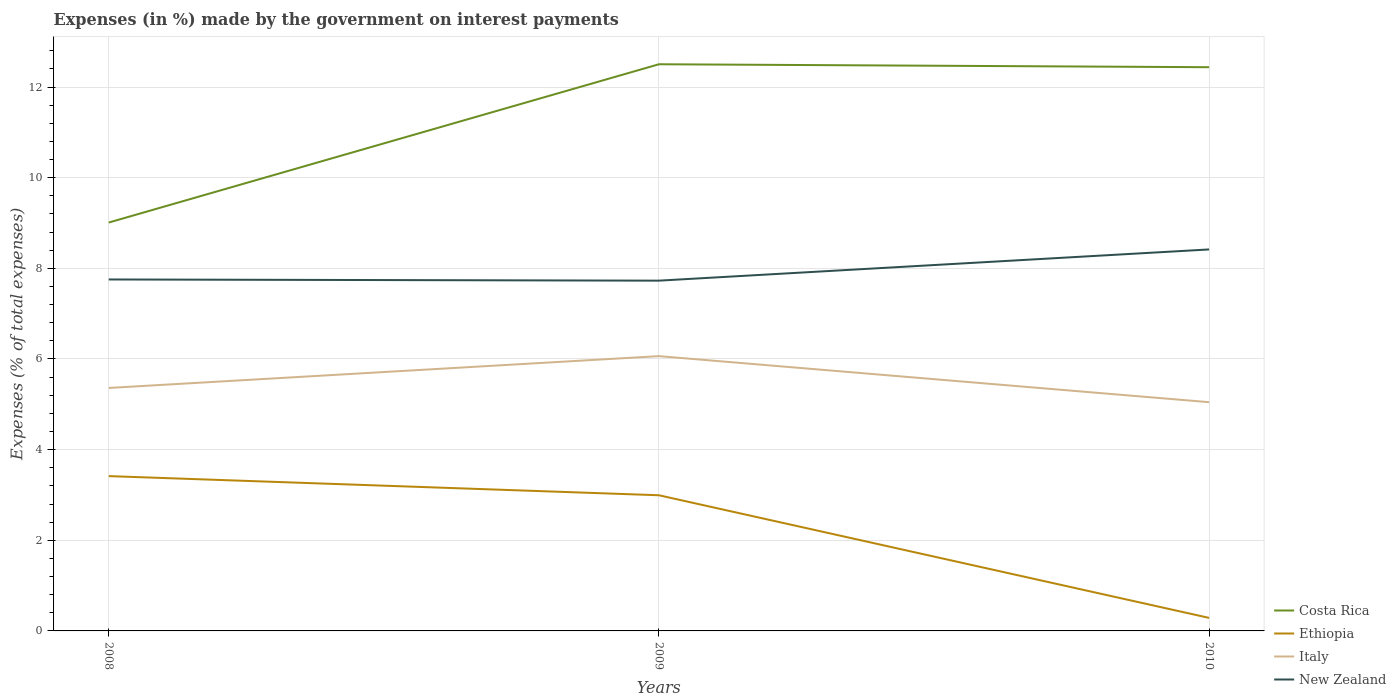How many different coloured lines are there?
Make the answer very short. 4. Does the line corresponding to Ethiopia intersect with the line corresponding to New Zealand?
Provide a short and direct response. No. Across all years, what is the maximum percentage of expenses made by the government on interest payments in Italy?
Your answer should be compact. 5.05. What is the total percentage of expenses made by the government on interest payments in Ethiopia in the graph?
Keep it short and to the point. 3.13. What is the difference between the highest and the second highest percentage of expenses made by the government on interest payments in Costa Rica?
Provide a short and direct response. 3.49. What is the difference between the highest and the lowest percentage of expenses made by the government on interest payments in Costa Rica?
Offer a terse response. 2. Is the percentage of expenses made by the government on interest payments in Italy strictly greater than the percentage of expenses made by the government on interest payments in New Zealand over the years?
Your answer should be very brief. Yes. How many years are there in the graph?
Provide a succinct answer. 3. What is the difference between two consecutive major ticks on the Y-axis?
Give a very brief answer. 2. Are the values on the major ticks of Y-axis written in scientific E-notation?
Provide a short and direct response. No. Does the graph contain any zero values?
Your answer should be very brief. No. Does the graph contain grids?
Keep it short and to the point. Yes. Where does the legend appear in the graph?
Your answer should be very brief. Bottom right. What is the title of the graph?
Provide a succinct answer. Expenses (in %) made by the government on interest payments. What is the label or title of the Y-axis?
Your response must be concise. Expenses (% of total expenses). What is the Expenses (% of total expenses) of Costa Rica in 2008?
Offer a terse response. 9.01. What is the Expenses (% of total expenses) of Ethiopia in 2008?
Your answer should be very brief. 3.42. What is the Expenses (% of total expenses) of Italy in 2008?
Offer a terse response. 5.36. What is the Expenses (% of total expenses) in New Zealand in 2008?
Make the answer very short. 7.75. What is the Expenses (% of total expenses) in Costa Rica in 2009?
Keep it short and to the point. 12.5. What is the Expenses (% of total expenses) in Ethiopia in 2009?
Your answer should be very brief. 2.99. What is the Expenses (% of total expenses) of Italy in 2009?
Provide a short and direct response. 6.06. What is the Expenses (% of total expenses) of New Zealand in 2009?
Provide a short and direct response. 7.73. What is the Expenses (% of total expenses) of Costa Rica in 2010?
Offer a very short reply. 12.44. What is the Expenses (% of total expenses) in Ethiopia in 2010?
Offer a terse response. 0.29. What is the Expenses (% of total expenses) of Italy in 2010?
Provide a short and direct response. 5.05. What is the Expenses (% of total expenses) in New Zealand in 2010?
Make the answer very short. 8.42. Across all years, what is the maximum Expenses (% of total expenses) of Costa Rica?
Provide a short and direct response. 12.5. Across all years, what is the maximum Expenses (% of total expenses) of Ethiopia?
Provide a short and direct response. 3.42. Across all years, what is the maximum Expenses (% of total expenses) in Italy?
Your answer should be compact. 6.06. Across all years, what is the maximum Expenses (% of total expenses) in New Zealand?
Keep it short and to the point. 8.42. Across all years, what is the minimum Expenses (% of total expenses) in Costa Rica?
Keep it short and to the point. 9.01. Across all years, what is the minimum Expenses (% of total expenses) of Ethiopia?
Ensure brevity in your answer.  0.29. Across all years, what is the minimum Expenses (% of total expenses) in Italy?
Offer a very short reply. 5.05. Across all years, what is the minimum Expenses (% of total expenses) of New Zealand?
Provide a short and direct response. 7.73. What is the total Expenses (% of total expenses) in Costa Rica in the graph?
Offer a terse response. 33.95. What is the total Expenses (% of total expenses) of Ethiopia in the graph?
Ensure brevity in your answer.  6.7. What is the total Expenses (% of total expenses) in Italy in the graph?
Provide a succinct answer. 16.47. What is the total Expenses (% of total expenses) of New Zealand in the graph?
Your answer should be very brief. 23.9. What is the difference between the Expenses (% of total expenses) in Costa Rica in 2008 and that in 2009?
Your answer should be compact. -3.49. What is the difference between the Expenses (% of total expenses) in Ethiopia in 2008 and that in 2009?
Keep it short and to the point. 0.42. What is the difference between the Expenses (% of total expenses) of Italy in 2008 and that in 2009?
Keep it short and to the point. -0.7. What is the difference between the Expenses (% of total expenses) in New Zealand in 2008 and that in 2009?
Make the answer very short. 0.03. What is the difference between the Expenses (% of total expenses) of Costa Rica in 2008 and that in 2010?
Your response must be concise. -3.43. What is the difference between the Expenses (% of total expenses) of Ethiopia in 2008 and that in 2010?
Ensure brevity in your answer.  3.13. What is the difference between the Expenses (% of total expenses) in Italy in 2008 and that in 2010?
Your answer should be compact. 0.31. What is the difference between the Expenses (% of total expenses) of New Zealand in 2008 and that in 2010?
Provide a short and direct response. -0.66. What is the difference between the Expenses (% of total expenses) in Costa Rica in 2009 and that in 2010?
Provide a succinct answer. 0.07. What is the difference between the Expenses (% of total expenses) in Ethiopia in 2009 and that in 2010?
Keep it short and to the point. 2.71. What is the difference between the Expenses (% of total expenses) of Italy in 2009 and that in 2010?
Offer a very short reply. 1.02. What is the difference between the Expenses (% of total expenses) in New Zealand in 2009 and that in 2010?
Provide a short and direct response. -0.69. What is the difference between the Expenses (% of total expenses) of Costa Rica in 2008 and the Expenses (% of total expenses) of Ethiopia in 2009?
Give a very brief answer. 6.02. What is the difference between the Expenses (% of total expenses) of Costa Rica in 2008 and the Expenses (% of total expenses) of Italy in 2009?
Give a very brief answer. 2.95. What is the difference between the Expenses (% of total expenses) of Costa Rica in 2008 and the Expenses (% of total expenses) of New Zealand in 2009?
Give a very brief answer. 1.28. What is the difference between the Expenses (% of total expenses) of Ethiopia in 2008 and the Expenses (% of total expenses) of Italy in 2009?
Offer a terse response. -2.65. What is the difference between the Expenses (% of total expenses) of Ethiopia in 2008 and the Expenses (% of total expenses) of New Zealand in 2009?
Keep it short and to the point. -4.31. What is the difference between the Expenses (% of total expenses) of Italy in 2008 and the Expenses (% of total expenses) of New Zealand in 2009?
Make the answer very short. -2.37. What is the difference between the Expenses (% of total expenses) in Costa Rica in 2008 and the Expenses (% of total expenses) in Ethiopia in 2010?
Your response must be concise. 8.72. What is the difference between the Expenses (% of total expenses) in Costa Rica in 2008 and the Expenses (% of total expenses) in Italy in 2010?
Your answer should be very brief. 3.96. What is the difference between the Expenses (% of total expenses) in Costa Rica in 2008 and the Expenses (% of total expenses) in New Zealand in 2010?
Give a very brief answer. 0.59. What is the difference between the Expenses (% of total expenses) of Ethiopia in 2008 and the Expenses (% of total expenses) of Italy in 2010?
Give a very brief answer. -1.63. What is the difference between the Expenses (% of total expenses) of Ethiopia in 2008 and the Expenses (% of total expenses) of New Zealand in 2010?
Your answer should be very brief. -5. What is the difference between the Expenses (% of total expenses) in Italy in 2008 and the Expenses (% of total expenses) in New Zealand in 2010?
Offer a very short reply. -3.06. What is the difference between the Expenses (% of total expenses) in Costa Rica in 2009 and the Expenses (% of total expenses) in Ethiopia in 2010?
Your answer should be compact. 12.22. What is the difference between the Expenses (% of total expenses) in Costa Rica in 2009 and the Expenses (% of total expenses) in Italy in 2010?
Your answer should be very brief. 7.46. What is the difference between the Expenses (% of total expenses) of Costa Rica in 2009 and the Expenses (% of total expenses) of New Zealand in 2010?
Provide a succinct answer. 4.09. What is the difference between the Expenses (% of total expenses) in Ethiopia in 2009 and the Expenses (% of total expenses) in Italy in 2010?
Provide a succinct answer. -2.05. What is the difference between the Expenses (% of total expenses) of Ethiopia in 2009 and the Expenses (% of total expenses) of New Zealand in 2010?
Provide a succinct answer. -5.42. What is the difference between the Expenses (% of total expenses) in Italy in 2009 and the Expenses (% of total expenses) in New Zealand in 2010?
Your response must be concise. -2.35. What is the average Expenses (% of total expenses) in Costa Rica per year?
Your answer should be very brief. 11.32. What is the average Expenses (% of total expenses) of Ethiopia per year?
Keep it short and to the point. 2.23. What is the average Expenses (% of total expenses) in Italy per year?
Offer a very short reply. 5.49. What is the average Expenses (% of total expenses) of New Zealand per year?
Your response must be concise. 7.97. In the year 2008, what is the difference between the Expenses (% of total expenses) of Costa Rica and Expenses (% of total expenses) of Ethiopia?
Your answer should be very brief. 5.6. In the year 2008, what is the difference between the Expenses (% of total expenses) in Costa Rica and Expenses (% of total expenses) in Italy?
Provide a short and direct response. 3.65. In the year 2008, what is the difference between the Expenses (% of total expenses) in Costa Rica and Expenses (% of total expenses) in New Zealand?
Provide a short and direct response. 1.26. In the year 2008, what is the difference between the Expenses (% of total expenses) of Ethiopia and Expenses (% of total expenses) of Italy?
Your answer should be very brief. -1.95. In the year 2008, what is the difference between the Expenses (% of total expenses) in Ethiopia and Expenses (% of total expenses) in New Zealand?
Make the answer very short. -4.34. In the year 2008, what is the difference between the Expenses (% of total expenses) of Italy and Expenses (% of total expenses) of New Zealand?
Provide a succinct answer. -2.39. In the year 2009, what is the difference between the Expenses (% of total expenses) of Costa Rica and Expenses (% of total expenses) of Ethiopia?
Offer a terse response. 9.51. In the year 2009, what is the difference between the Expenses (% of total expenses) of Costa Rica and Expenses (% of total expenses) of Italy?
Offer a very short reply. 6.44. In the year 2009, what is the difference between the Expenses (% of total expenses) in Costa Rica and Expenses (% of total expenses) in New Zealand?
Your answer should be compact. 4.77. In the year 2009, what is the difference between the Expenses (% of total expenses) of Ethiopia and Expenses (% of total expenses) of Italy?
Ensure brevity in your answer.  -3.07. In the year 2009, what is the difference between the Expenses (% of total expenses) of Ethiopia and Expenses (% of total expenses) of New Zealand?
Your answer should be compact. -4.74. In the year 2009, what is the difference between the Expenses (% of total expenses) of Italy and Expenses (% of total expenses) of New Zealand?
Give a very brief answer. -1.67. In the year 2010, what is the difference between the Expenses (% of total expenses) of Costa Rica and Expenses (% of total expenses) of Ethiopia?
Your response must be concise. 12.15. In the year 2010, what is the difference between the Expenses (% of total expenses) of Costa Rica and Expenses (% of total expenses) of Italy?
Ensure brevity in your answer.  7.39. In the year 2010, what is the difference between the Expenses (% of total expenses) in Costa Rica and Expenses (% of total expenses) in New Zealand?
Your response must be concise. 4.02. In the year 2010, what is the difference between the Expenses (% of total expenses) in Ethiopia and Expenses (% of total expenses) in Italy?
Provide a short and direct response. -4.76. In the year 2010, what is the difference between the Expenses (% of total expenses) of Ethiopia and Expenses (% of total expenses) of New Zealand?
Make the answer very short. -8.13. In the year 2010, what is the difference between the Expenses (% of total expenses) in Italy and Expenses (% of total expenses) in New Zealand?
Your answer should be compact. -3.37. What is the ratio of the Expenses (% of total expenses) in Costa Rica in 2008 to that in 2009?
Your response must be concise. 0.72. What is the ratio of the Expenses (% of total expenses) of Ethiopia in 2008 to that in 2009?
Offer a very short reply. 1.14. What is the ratio of the Expenses (% of total expenses) of Italy in 2008 to that in 2009?
Offer a very short reply. 0.88. What is the ratio of the Expenses (% of total expenses) of New Zealand in 2008 to that in 2009?
Provide a short and direct response. 1. What is the ratio of the Expenses (% of total expenses) in Costa Rica in 2008 to that in 2010?
Your answer should be compact. 0.72. What is the ratio of the Expenses (% of total expenses) in Ethiopia in 2008 to that in 2010?
Keep it short and to the point. 11.88. What is the ratio of the Expenses (% of total expenses) in Italy in 2008 to that in 2010?
Provide a short and direct response. 1.06. What is the ratio of the Expenses (% of total expenses) in New Zealand in 2008 to that in 2010?
Provide a short and direct response. 0.92. What is the ratio of the Expenses (% of total expenses) of Costa Rica in 2009 to that in 2010?
Your answer should be compact. 1.01. What is the ratio of the Expenses (% of total expenses) of Ethiopia in 2009 to that in 2010?
Provide a short and direct response. 10.41. What is the ratio of the Expenses (% of total expenses) in Italy in 2009 to that in 2010?
Offer a very short reply. 1.2. What is the ratio of the Expenses (% of total expenses) of New Zealand in 2009 to that in 2010?
Offer a very short reply. 0.92. What is the difference between the highest and the second highest Expenses (% of total expenses) in Costa Rica?
Offer a terse response. 0.07. What is the difference between the highest and the second highest Expenses (% of total expenses) in Ethiopia?
Your response must be concise. 0.42. What is the difference between the highest and the second highest Expenses (% of total expenses) of Italy?
Keep it short and to the point. 0.7. What is the difference between the highest and the second highest Expenses (% of total expenses) of New Zealand?
Provide a succinct answer. 0.66. What is the difference between the highest and the lowest Expenses (% of total expenses) of Costa Rica?
Provide a succinct answer. 3.49. What is the difference between the highest and the lowest Expenses (% of total expenses) in Ethiopia?
Your answer should be very brief. 3.13. What is the difference between the highest and the lowest Expenses (% of total expenses) in Italy?
Offer a terse response. 1.02. What is the difference between the highest and the lowest Expenses (% of total expenses) of New Zealand?
Provide a succinct answer. 0.69. 